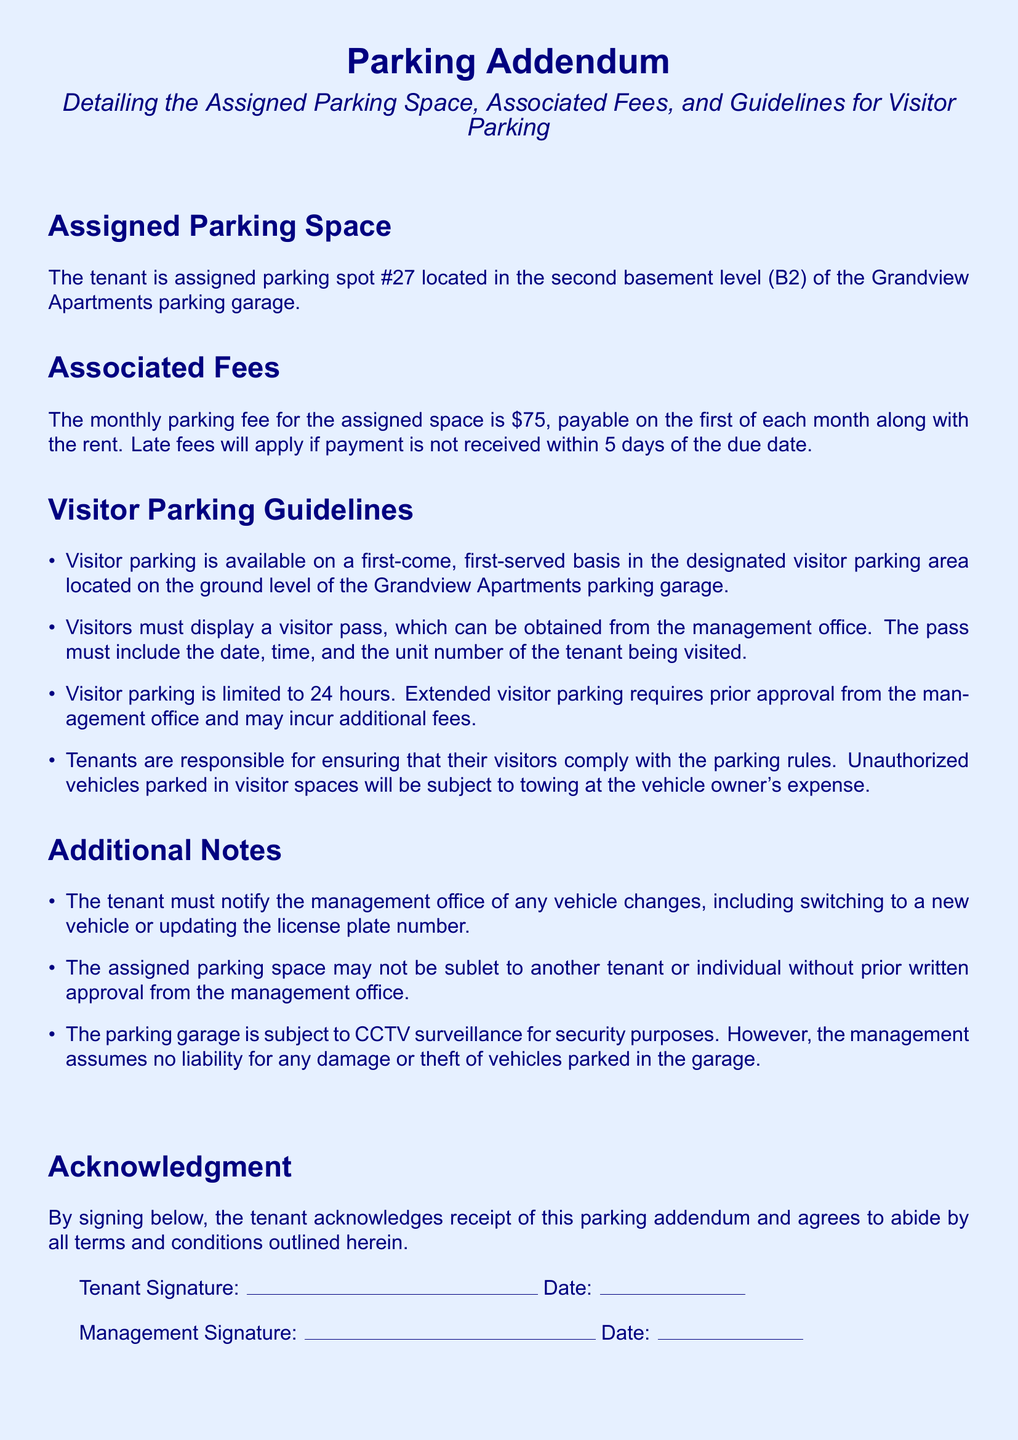What is the assigned parking space number? The assigned parking space number is explicitly mentioned in the document as spot #27.
Answer: spot #27 Where is the assigned parking space located? The document specifies that the assigned parking space is located in the second basement level (B2) of the Grandview Apartments parking garage.
Answer: second basement level (B2) What is the monthly parking fee? The document indicates that the monthly parking fee for the assigned space is stated as $75.
Answer: $75 How long can visitors park in visitor spaces? The guidelines specify that visitor parking is limited to 24 hours.
Answer: 24 hours What must visitors display while parked? The visitors are required to display a visitor pass that can be obtained from the management office.
Answer: visitor pass What happens if payment is not received within 5 days? The document outlines that late fees will apply if payment is not received within 5 days of the due date.
Answer: late fees apply What must tenants do if they change their vehicle? The tenant must notify the management office of any vehicle changes, as stated in the document.
Answer: notify the management office Can the assigned parking space be sublet? The document clearly states that the assigned parking space may not be sublet without prior written approval from the management office.
Answer: may not be sublet What type of surveillance is mentioned for the parking garage? The document mentions that the parking garage is subject to CCTV surveillance for security purposes.
Answer: CCTV surveillance 